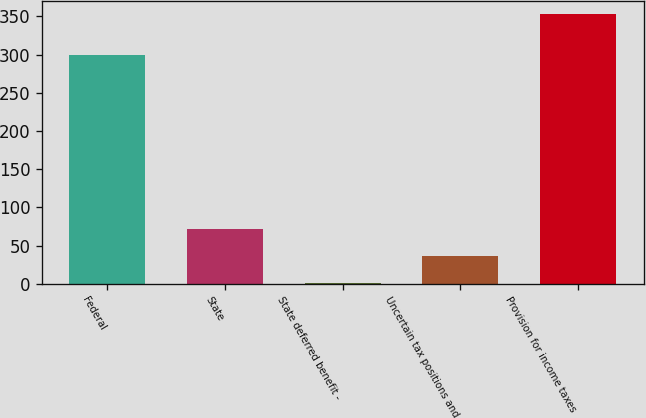Convert chart. <chart><loc_0><loc_0><loc_500><loc_500><bar_chart><fcel>Federal<fcel>State<fcel>State deferred benefit -<fcel>Uncertain tax positions and<fcel>Provision for income taxes<nl><fcel>299.5<fcel>71.66<fcel>1.4<fcel>36.53<fcel>352.7<nl></chart> 